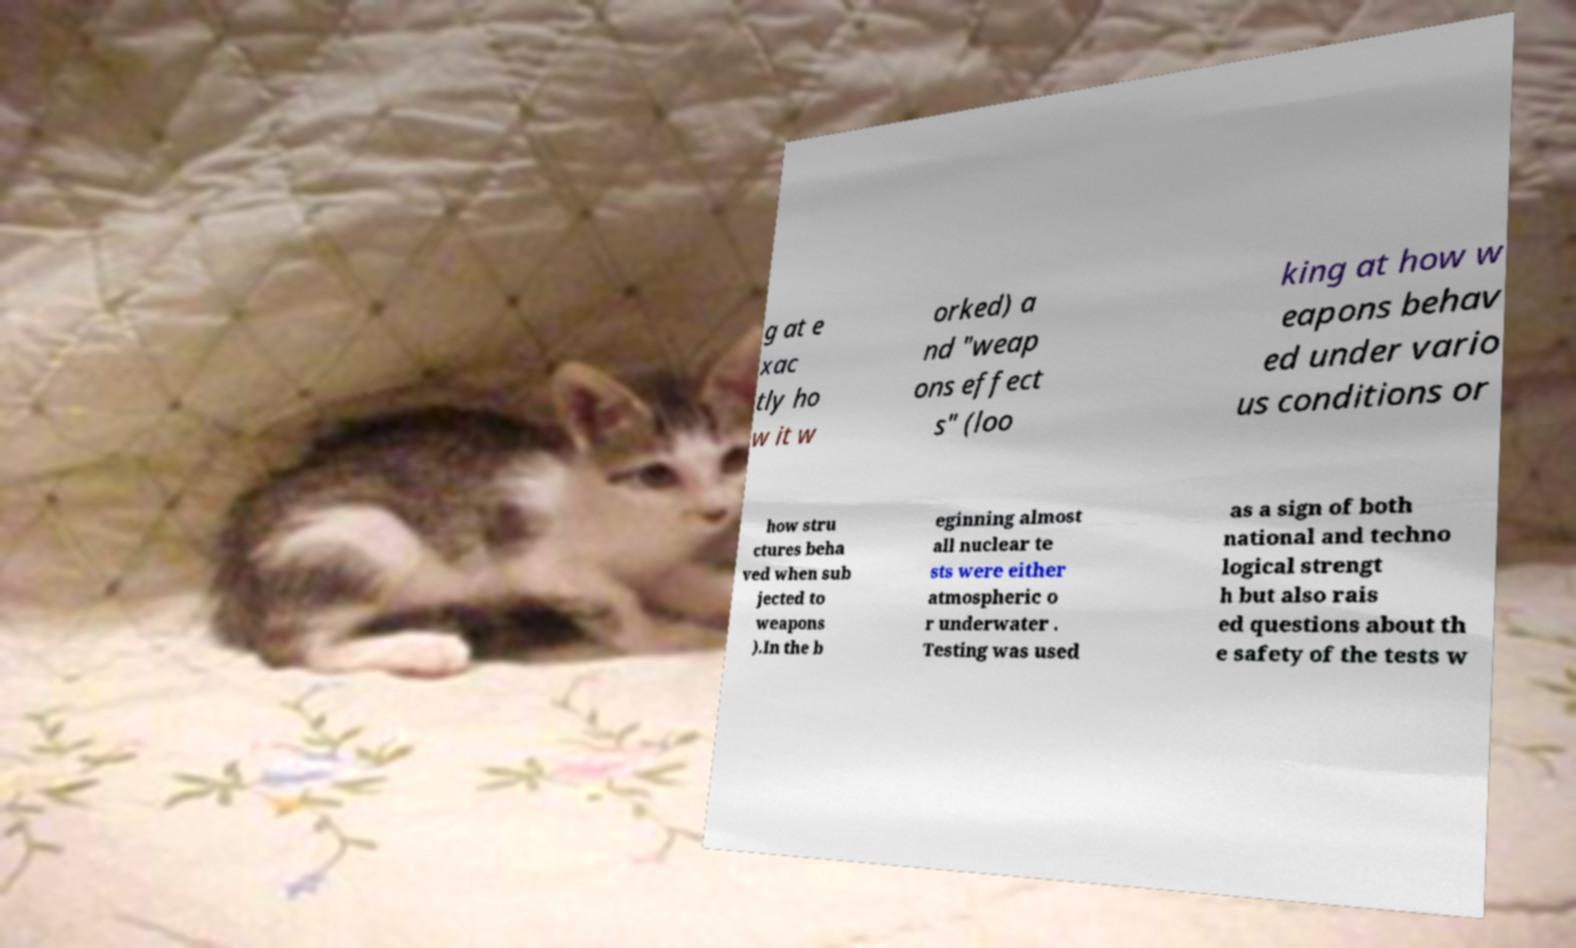There's text embedded in this image that I need extracted. Can you transcribe it verbatim? g at e xac tly ho w it w orked) a nd "weap ons effect s" (loo king at how w eapons behav ed under vario us conditions or how stru ctures beha ved when sub jected to weapons ).In the b eginning almost all nuclear te sts were either atmospheric o r underwater . Testing was used as a sign of both national and techno logical strengt h but also rais ed questions about th e safety of the tests w 